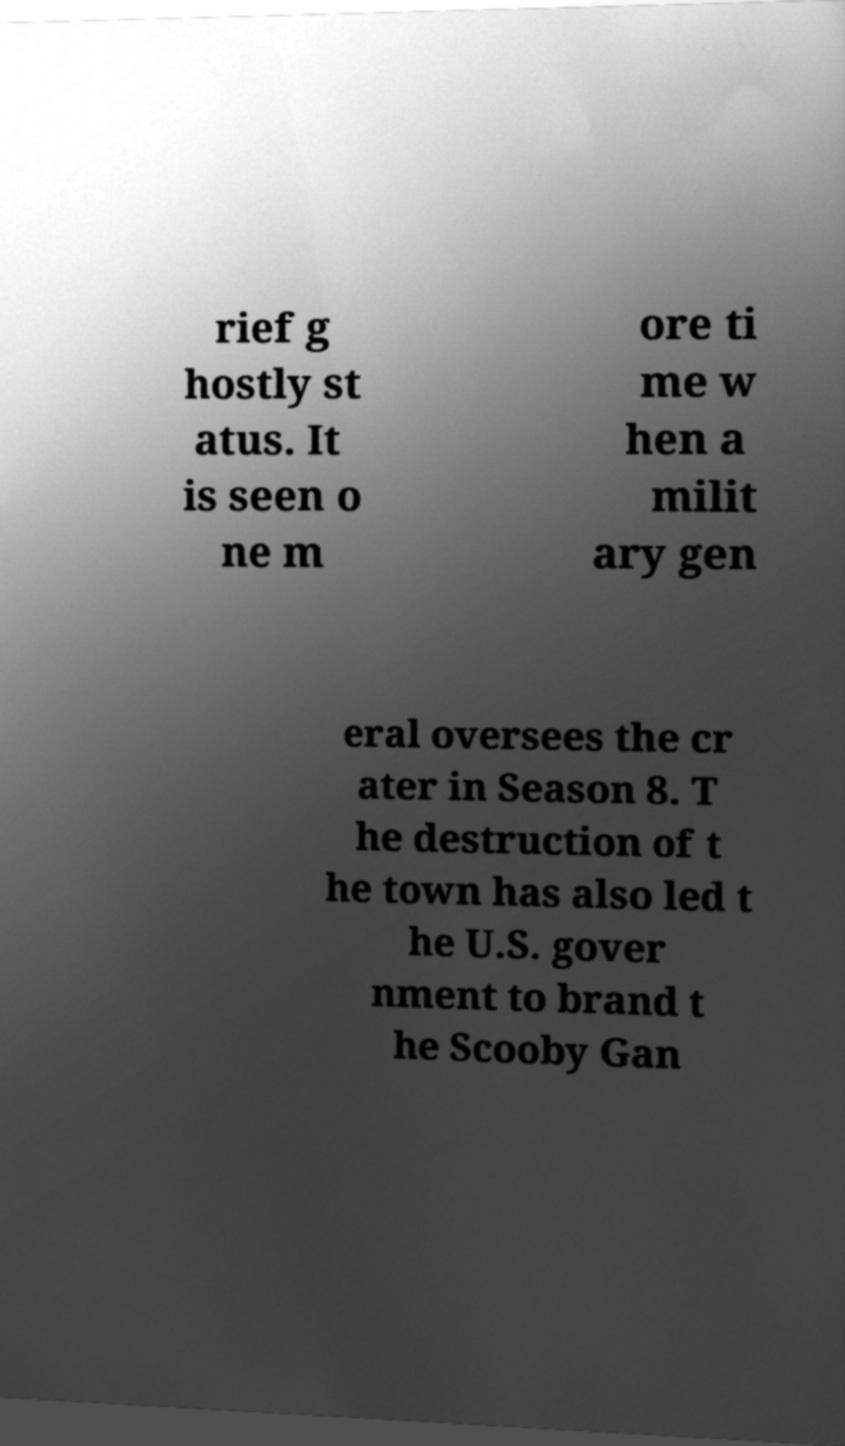For documentation purposes, I need the text within this image transcribed. Could you provide that? rief g hostly st atus. It is seen o ne m ore ti me w hen a milit ary gen eral oversees the cr ater in Season 8. T he destruction of t he town has also led t he U.S. gover nment to brand t he Scooby Gan 